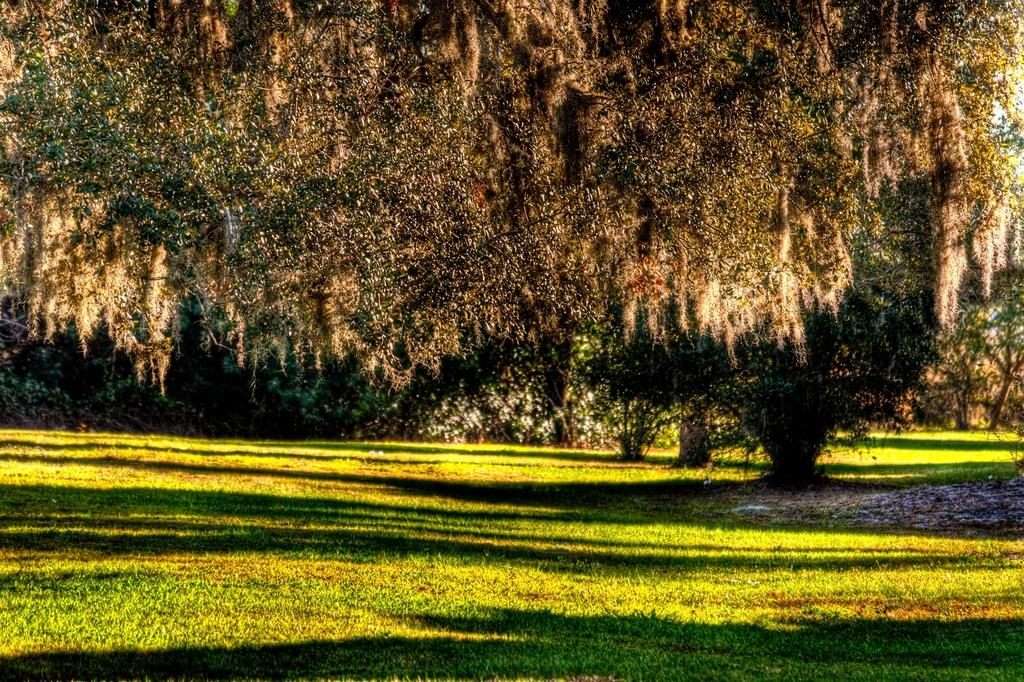What type of vegetation can be seen in the image? There is grass, plants, and trees in the image. Can you describe the natural environment depicted in the image? The image features a variety of vegetation, including grass, plants, and trees. What type of fruit is hanging from the trees in the image? There is no fruit visible in the image; it only features grass, plants, and trees. 